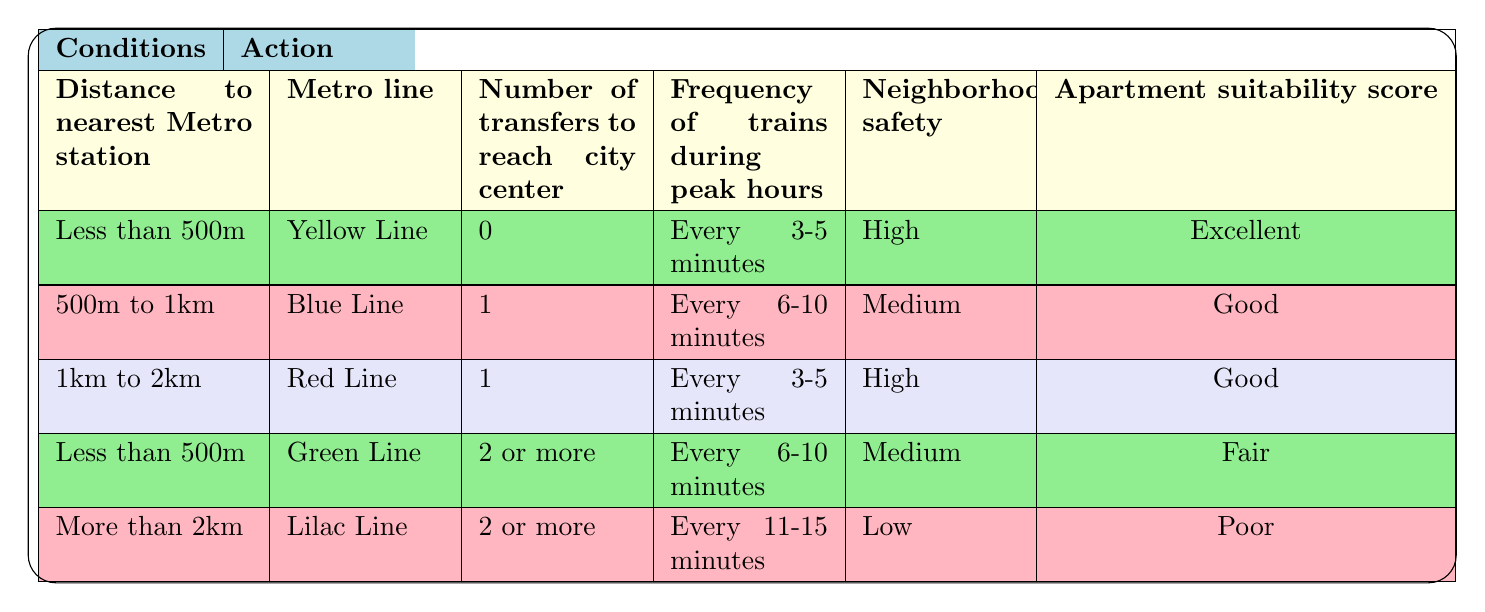What is the suitability score for an apartment that is less than 500 meters from a Yellow Line station with no transfers? The table indicates that for an apartment with these conditions, the suitability score is "Excellent."
Answer: Excellent How many transfer options are listed for apartments located more than 2 kilometers from the nearest Lilac Line station? According to the table, the only transfer option listed for this condition is "2 or more."
Answer: 2 or more Is there an option for an apartment with a frequency of trains every 6-10 minutes and high neighborhood safety? The table provides no such option; apartments with such frequency and safety criteria do not correspond to any suitability score listed.
Answer: No What is the average distance to the nearest Metro station that corresponds to an "Excellent" suitability score? The only distance condition that results in an "Excellent" score is "Less than 500m." Since there's only one data point, the average is also "Less than 500m."
Answer: Less than 500m If I want to live close to the city center, which is the best Metro line to choose if I want to avoid transfers? The table indicates that the Yellow Line is the best option since it has no transfers required; it also corresponds to an "Excellent" score.
Answer: Yellow Line What is the minimum frequency of trains during peak hours needed to achieve at least a "Good" suitability score? By examining the table, the minimum frequency of trains that results in at least a "Good" score is "Every 6-10 minutes," as seen in the second entry.
Answer: Every 6-10 minutes Are there any apartments that score "Fair" with a distance to the nearest Metro station between 1 and 2 kilometers? The table shows that there are no conditions matching that description; the only entry that scores "Fair" has a distance of less than 500m.
Answer: No What would be the suitability score for an apartment located between 500 meters and 1 kilometer from the Blue Line station, with a medium safety rating? Referring back to the table, this combination results in a "Good" suitability score.
Answer: Good 